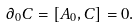Convert formula to latex. <formula><loc_0><loc_0><loc_500><loc_500>\partial _ { 0 } C = [ A _ { 0 } , C ] = 0 .</formula> 